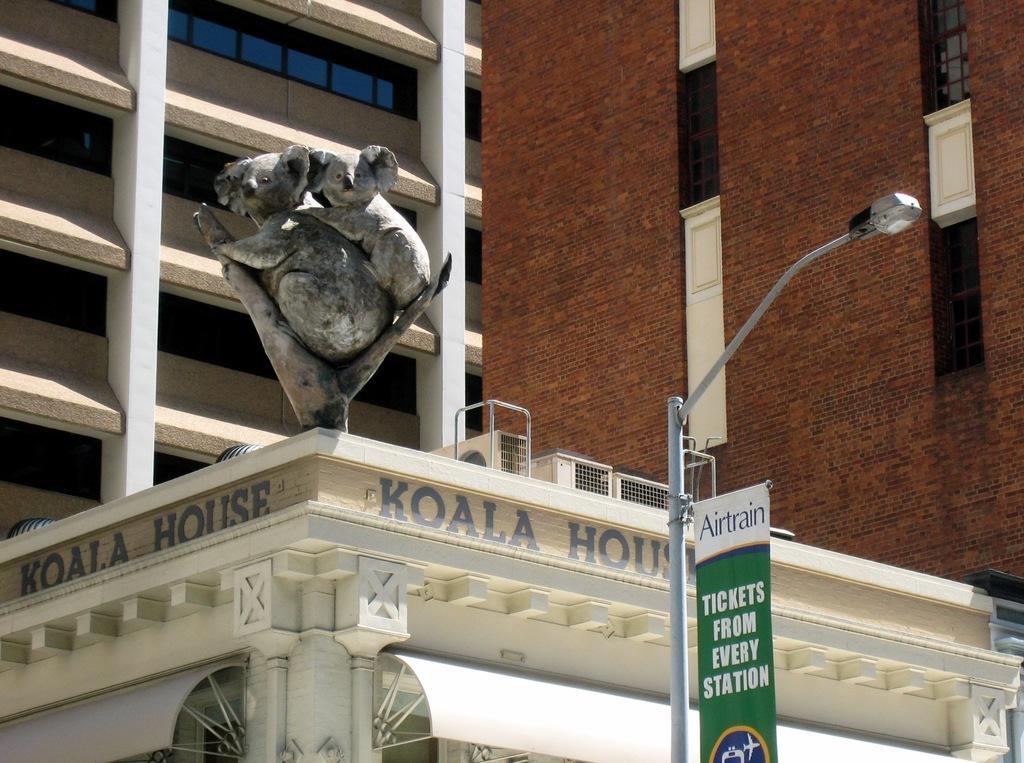Could you give a brief overview of what you see in this image? At the bottom of the picture, we see a building in white color. Beside that, we see a street light and a board in white and green color with some text written on it. In the middle of the picture, we see the statue. In the background, we see the buildings in brown, grey and white color. It has windows. 